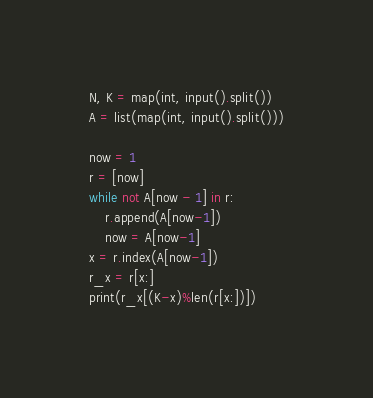<code> <loc_0><loc_0><loc_500><loc_500><_Python_>N, K = map(int, input().split())
A = list(map(int, input().split()))

now = 1
r = [now]
while not A[now - 1] in r:
    r.append(A[now-1])
    now = A[now-1]
x = r.index(A[now-1])
r_x = r[x:]
print(r_x[(K-x)%len(r[x:])])
</code> 